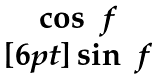<formula> <loc_0><loc_0><loc_500><loc_500>\begin{matrix} \cos \ f \\ [ 6 p t ] \sin \ f \end{matrix}</formula> 